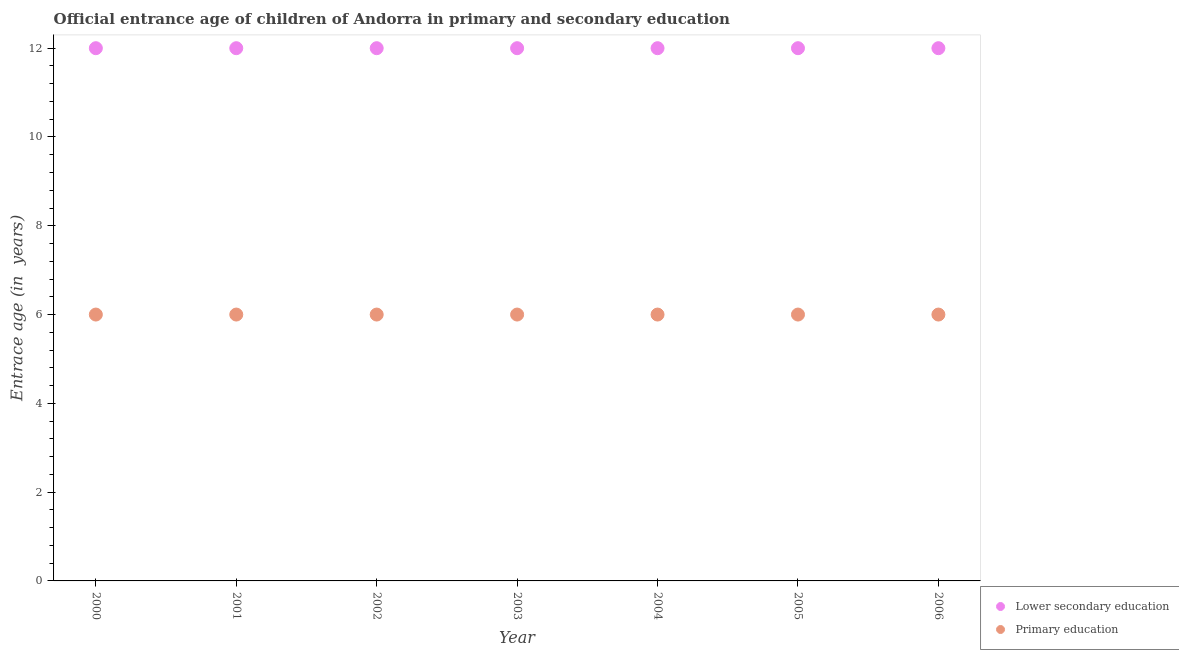How many different coloured dotlines are there?
Provide a short and direct response. 2. What is the entrance age of chiildren in primary education in 2000?
Keep it short and to the point. 6. Across all years, what is the maximum entrance age of chiildren in primary education?
Your response must be concise. 6. Across all years, what is the minimum entrance age of children in lower secondary education?
Give a very brief answer. 12. In which year was the entrance age of chiildren in primary education minimum?
Ensure brevity in your answer.  2000. What is the total entrance age of chiildren in primary education in the graph?
Give a very brief answer. 42. What is the difference between the entrance age of children in lower secondary education in 2001 and that in 2005?
Make the answer very short. 0. What is the difference between the entrance age of chiildren in primary education in 2000 and the entrance age of children in lower secondary education in 2004?
Your response must be concise. -6. What is the average entrance age of children in lower secondary education per year?
Ensure brevity in your answer.  12. What is the ratio of the entrance age of children in lower secondary education in 2000 to that in 2005?
Give a very brief answer. 1. Is the difference between the entrance age of chiildren in primary education in 2005 and 2006 greater than the difference between the entrance age of children in lower secondary education in 2005 and 2006?
Your answer should be very brief. No. In how many years, is the entrance age of chiildren in primary education greater than the average entrance age of chiildren in primary education taken over all years?
Give a very brief answer. 0. Does the entrance age of chiildren in primary education monotonically increase over the years?
Your answer should be very brief. No. Is the entrance age of chiildren in primary education strictly less than the entrance age of children in lower secondary education over the years?
Provide a succinct answer. Yes. What is the difference between two consecutive major ticks on the Y-axis?
Keep it short and to the point. 2. Does the graph contain grids?
Offer a terse response. No. Where does the legend appear in the graph?
Make the answer very short. Bottom right. What is the title of the graph?
Ensure brevity in your answer.  Official entrance age of children of Andorra in primary and secondary education. What is the label or title of the Y-axis?
Offer a very short reply. Entrace age (in  years). What is the Entrace age (in  years) in Primary education in 2000?
Your answer should be compact. 6. What is the Entrace age (in  years) of Primary education in 2001?
Ensure brevity in your answer.  6. What is the Entrace age (in  years) in Lower secondary education in 2002?
Your response must be concise. 12. What is the Entrace age (in  years) of Primary education in 2002?
Keep it short and to the point. 6. What is the Entrace age (in  years) in Lower secondary education in 2003?
Make the answer very short. 12. What is the Entrace age (in  years) of Primary education in 2003?
Your answer should be compact. 6. What is the Entrace age (in  years) in Lower secondary education in 2004?
Provide a short and direct response. 12. What is the Entrace age (in  years) of Primary education in 2004?
Give a very brief answer. 6. What is the Entrace age (in  years) of Lower secondary education in 2005?
Make the answer very short. 12. What is the Entrace age (in  years) in Primary education in 2006?
Provide a succinct answer. 6. Across all years, what is the minimum Entrace age (in  years) of Primary education?
Ensure brevity in your answer.  6. What is the total Entrace age (in  years) in Lower secondary education in the graph?
Ensure brevity in your answer.  84. What is the total Entrace age (in  years) of Primary education in the graph?
Provide a short and direct response. 42. What is the difference between the Entrace age (in  years) of Lower secondary education in 2000 and that in 2001?
Your response must be concise. 0. What is the difference between the Entrace age (in  years) of Primary education in 2000 and that in 2001?
Your answer should be very brief. 0. What is the difference between the Entrace age (in  years) of Lower secondary education in 2000 and that in 2003?
Give a very brief answer. 0. What is the difference between the Entrace age (in  years) of Primary education in 2000 and that in 2005?
Provide a short and direct response. 0. What is the difference between the Entrace age (in  years) of Lower secondary education in 2001 and that in 2002?
Ensure brevity in your answer.  0. What is the difference between the Entrace age (in  years) in Primary education in 2001 and that in 2003?
Your answer should be very brief. 0. What is the difference between the Entrace age (in  years) in Primary education in 2001 and that in 2006?
Your answer should be very brief. 0. What is the difference between the Entrace age (in  years) in Primary education in 2002 and that in 2003?
Your answer should be very brief. 0. What is the difference between the Entrace age (in  years) in Primary education in 2002 and that in 2004?
Make the answer very short. 0. What is the difference between the Entrace age (in  years) in Lower secondary education in 2002 and that in 2005?
Provide a short and direct response. 0. What is the difference between the Entrace age (in  years) in Lower secondary education in 2002 and that in 2006?
Offer a terse response. 0. What is the difference between the Entrace age (in  years) in Primary education in 2002 and that in 2006?
Offer a very short reply. 0. What is the difference between the Entrace age (in  years) in Primary education in 2003 and that in 2004?
Your answer should be compact. 0. What is the difference between the Entrace age (in  years) in Lower secondary education in 2003 and that in 2005?
Provide a short and direct response. 0. What is the difference between the Entrace age (in  years) in Primary education in 2003 and that in 2005?
Your response must be concise. 0. What is the difference between the Entrace age (in  years) in Lower secondary education in 2003 and that in 2006?
Keep it short and to the point. 0. What is the difference between the Entrace age (in  years) of Primary education in 2003 and that in 2006?
Keep it short and to the point. 0. What is the difference between the Entrace age (in  years) of Lower secondary education in 2005 and that in 2006?
Offer a very short reply. 0. What is the difference between the Entrace age (in  years) in Lower secondary education in 2000 and the Entrace age (in  years) in Primary education in 2003?
Your answer should be compact. 6. What is the difference between the Entrace age (in  years) of Lower secondary education in 2000 and the Entrace age (in  years) of Primary education in 2004?
Provide a short and direct response. 6. What is the difference between the Entrace age (in  years) of Lower secondary education in 2000 and the Entrace age (in  years) of Primary education in 2005?
Keep it short and to the point. 6. What is the difference between the Entrace age (in  years) of Lower secondary education in 2000 and the Entrace age (in  years) of Primary education in 2006?
Make the answer very short. 6. What is the difference between the Entrace age (in  years) in Lower secondary education in 2001 and the Entrace age (in  years) in Primary education in 2003?
Your response must be concise. 6. What is the difference between the Entrace age (in  years) of Lower secondary education in 2001 and the Entrace age (in  years) of Primary education in 2004?
Offer a terse response. 6. What is the difference between the Entrace age (in  years) in Lower secondary education in 2001 and the Entrace age (in  years) in Primary education in 2005?
Your response must be concise. 6. What is the difference between the Entrace age (in  years) of Lower secondary education in 2001 and the Entrace age (in  years) of Primary education in 2006?
Provide a succinct answer. 6. What is the difference between the Entrace age (in  years) of Lower secondary education in 2002 and the Entrace age (in  years) of Primary education in 2004?
Ensure brevity in your answer.  6. What is the difference between the Entrace age (in  years) of Lower secondary education in 2002 and the Entrace age (in  years) of Primary education in 2005?
Keep it short and to the point. 6. What is the difference between the Entrace age (in  years) in Lower secondary education in 2003 and the Entrace age (in  years) in Primary education in 2005?
Your answer should be compact. 6. What is the difference between the Entrace age (in  years) in Lower secondary education in 2004 and the Entrace age (in  years) in Primary education in 2005?
Provide a succinct answer. 6. What is the average Entrace age (in  years) of Lower secondary education per year?
Offer a terse response. 12. What is the average Entrace age (in  years) in Primary education per year?
Ensure brevity in your answer.  6. In the year 2004, what is the difference between the Entrace age (in  years) of Lower secondary education and Entrace age (in  years) of Primary education?
Keep it short and to the point. 6. In the year 2006, what is the difference between the Entrace age (in  years) of Lower secondary education and Entrace age (in  years) of Primary education?
Your response must be concise. 6. What is the ratio of the Entrace age (in  years) of Primary education in 2000 to that in 2001?
Make the answer very short. 1. What is the ratio of the Entrace age (in  years) of Primary education in 2000 to that in 2002?
Offer a terse response. 1. What is the ratio of the Entrace age (in  years) of Primary education in 2000 to that in 2003?
Your answer should be compact. 1. What is the ratio of the Entrace age (in  years) in Primary education in 2000 to that in 2005?
Give a very brief answer. 1. What is the ratio of the Entrace age (in  years) in Primary education in 2001 to that in 2002?
Offer a very short reply. 1. What is the ratio of the Entrace age (in  years) in Primary education in 2001 to that in 2003?
Give a very brief answer. 1. What is the ratio of the Entrace age (in  years) of Lower secondary education in 2001 to that in 2004?
Your answer should be very brief. 1. What is the ratio of the Entrace age (in  years) of Primary education in 2001 to that in 2004?
Give a very brief answer. 1. What is the ratio of the Entrace age (in  years) of Primary education in 2001 to that in 2005?
Make the answer very short. 1. What is the ratio of the Entrace age (in  years) in Lower secondary education in 2001 to that in 2006?
Your answer should be very brief. 1. What is the ratio of the Entrace age (in  years) in Lower secondary education in 2002 to that in 2004?
Make the answer very short. 1. What is the ratio of the Entrace age (in  years) of Lower secondary education in 2002 to that in 2006?
Your response must be concise. 1. What is the ratio of the Entrace age (in  years) in Lower secondary education in 2003 to that in 2004?
Make the answer very short. 1. What is the ratio of the Entrace age (in  years) of Primary education in 2003 to that in 2004?
Make the answer very short. 1. What is the ratio of the Entrace age (in  years) in Lower secondary education in 2003 to that in 2005?
Keep it short and to the point. 1. What is the ratio of the Entrace age (in  years) in Lower secondary education in 2003 to that in 2006?
Offer a terse response. 1. What is the ratio of the Entrace age (in  years) of Lower secondary education in 2004 to that in 2005?
Your answer should be very brief. 1. What is the ratio of the Entrace age (in  years) of Primary education in 2004 to that in 2005?
Your response must be concise. 1. What is the ratio of the Entrace age (in  years) in Primary education in 2004 to that in 2006?
Make the answer very short. 1. What is the ratio of the Entrace age (in  years) of Lower secondary education in 2005 to that in 2006?
Provide a short and direct response. 1. What is the ratio of the Entrace age (in  years) of Primary education in 2005 to that in 2006?
Make the answer very short. 1. What is the difference between the highest and the second highest Entrace age (in  years) of Lower secondary education?
Your answer should be compact. 0. What is the difference between the highest and the lowest Entrace age (in  years) of Lower secondary education?
Provide a succinct answer. 0. 